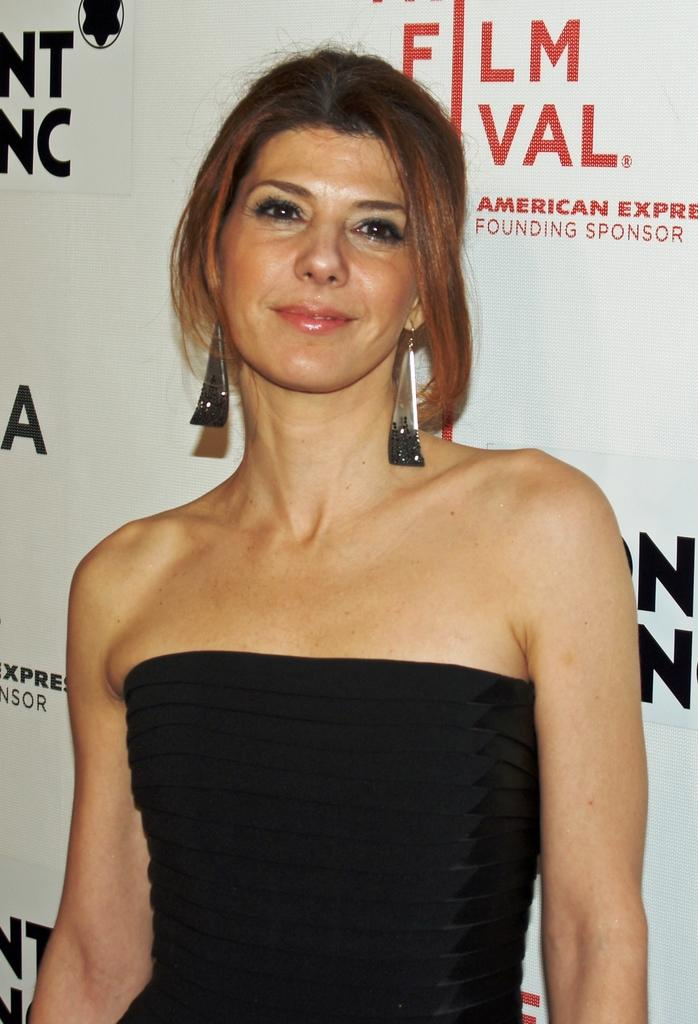What is the main subject of the image? There is a person standing in the center of the image. Where is the person standing? The person is standing on the floor. What can be seen in the background of the image? There is an advertisement in the background of the image. What type of rice is being cooked in the image? There is no rice present in the image; it features a person standing on the floor with an advertisement in the background. Can you see any ants in the image? There are no ants visible in the image. 